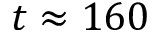Convert formula to latex. <formula><loc_0><loc_0><loc_500><loc_500>t \approx 1 6 0</formula> 